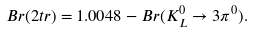Convert formula to latex. <formula><loc_0><loc_0><loc_500><loc_500>B r ( 2 t r ) = 1 . 0 0 4 8 - B r ( K ^ { 0 } _ { L } \rightarrow 3 \pi ^ { 0 } ) .</formula> 